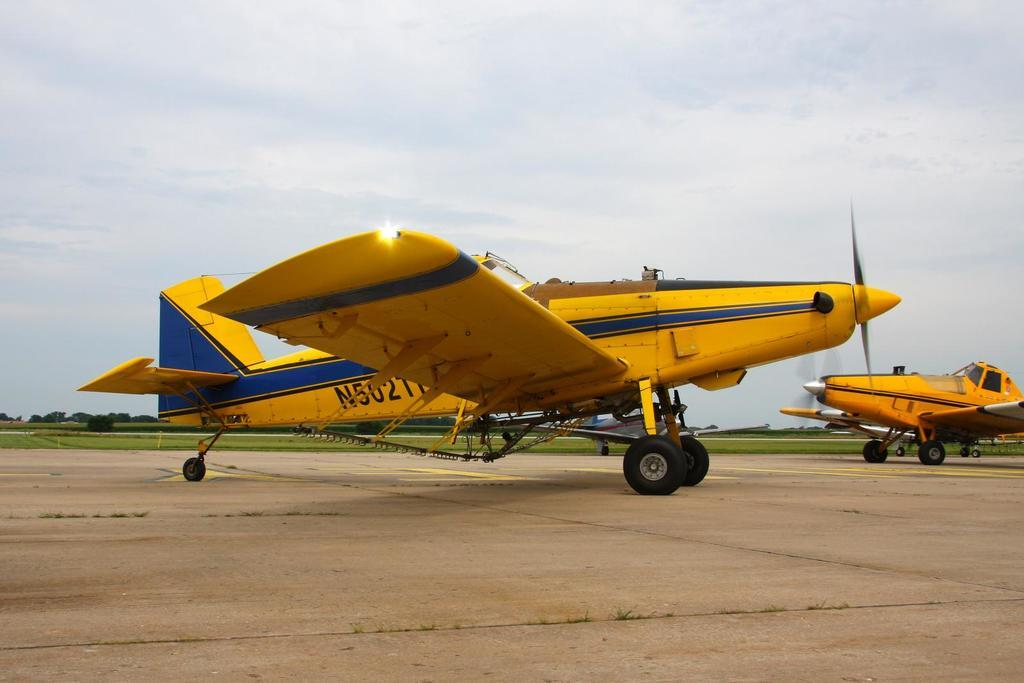<image>
Summarize the visual content of the image. A beautiful yellow and blue plane has the identifier N5021 